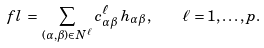Convert formula to latex. <formula><loc_0><loc_0><loc_500><loc_500>\ f l \, = \, \sum _ { ( \alpha , \beta ) \in N ^ { \ell } } c ^ { \ell } _ { \alpha \beta } \, h _ { \alpha \beta } , \quad \ell = 1 , \dots , p .</formula> 